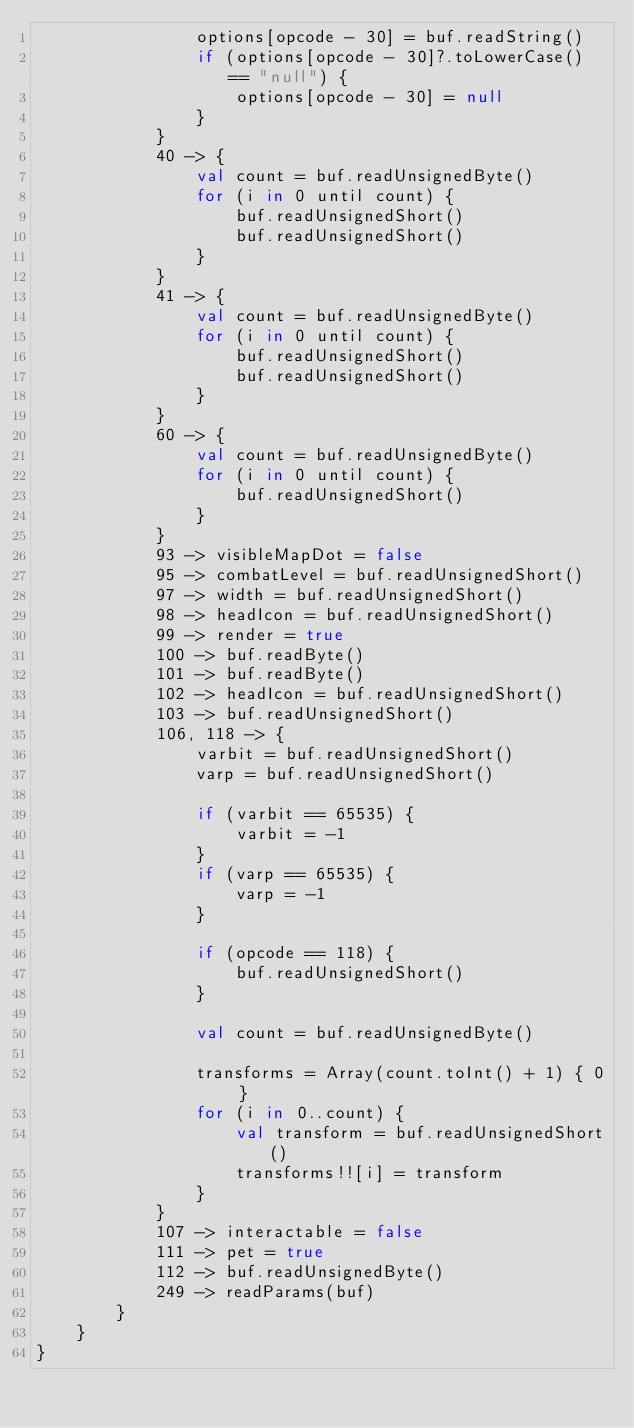Convert code to text. <code><loc_0><loc_0><loc_500><loc_500><_Kotlin_>                options[opcode - 30] = buf.readString()
                if (options[opcode - 30]?.toLowerCase() == "null") {
                    options[opcode - 30] = null
                }
            }
            40 -> {
                val count = buf.readUnsignedByte()
                for (i in 0 until count) {
                    buf.readUnsignedShort()
                    buf.readUnsignedShort()
                }
            }
            41 -> {
                val count = buf.readUnsignedByte()
                for (i in 0 until count) {
                    buf.readUnsignedShort()
                    buf.readUnsignedShort()
                }
            }
            60 -> {
                val count = buf.readUnsignedByte()
                for (i in 0 until count) {
                    buf.readUnsignedShort()
                }
            }
            93 -> visibleMapDot = false
            95 -> combatLevel = buf.readUnsignedShort()
            97 -> width = buf.readUnsignedShort()
            98 -> headIcon = buf.readUnsignedShort()
            99 -> render = true
            100 -> buf.readByte()
            101 -> buf.readByte()
            102 -> headIcon = buf.readUnsignedShort()
            103 -> buf.readUnsignedShort()
            106, 118 -> {
                varbit = buf.readUnsignedShort()
                varp = buf.readUnsignedShort()

                if (varbit == 65535) {
                    varbit = -1
                }
                if (varp == 65535) {
                    varp = -1
                }

                if (opcode == 118) {
                    buf.readUnsignedShort()
                }

                val count = buf.readUnsignedByte()

                transforms = Array(count.toInt() + 1) { 0 }
                for (i in 0..count) {
                    val transform = buf.readUnsignedShort()
                    transforms!![i] = transform
                }
            }
            107 -> interactable = false
            111 -> pet = true
            112 -> buf.readUnsignedByte()
            249 -> readParams(buf)
        }
    }
}</code> 